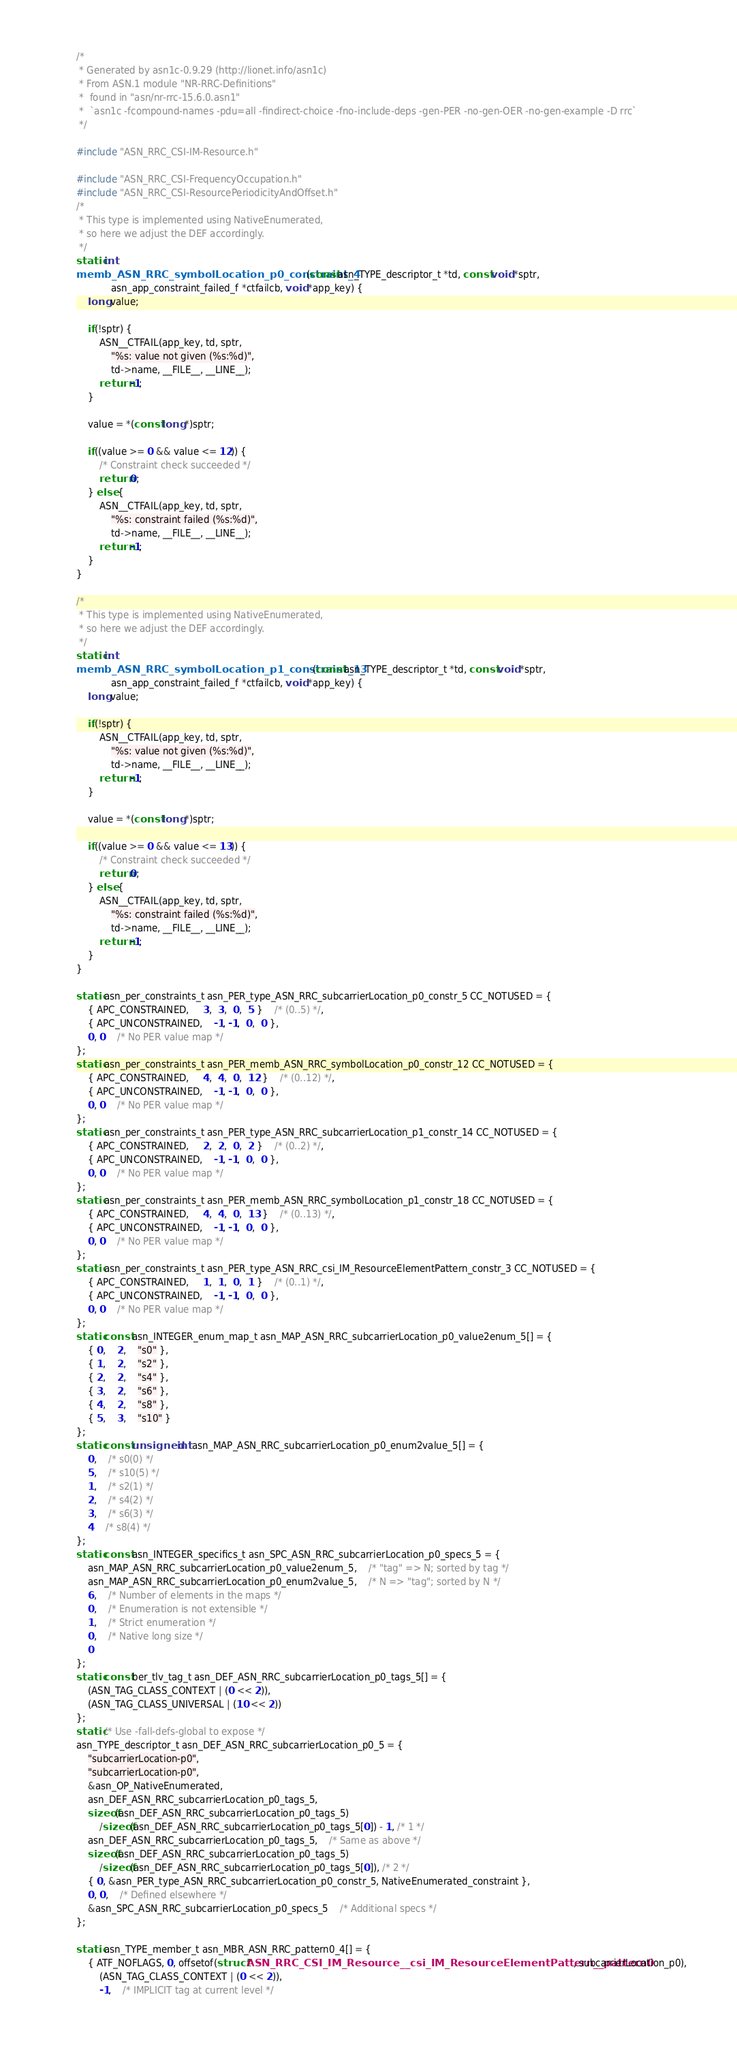<code> <loc_0><loc_0><loc_500><loc_500><_C_>/*
 * Generated by asn1c-0.9.29 (http://lionet.info/asn1c)
 * From ASN.1 module "NR-RRC-Definitions"
 * 	found in "asn/nr-rrc-15.6.0.asn1"
 * 	`asn1c -fcompound-names -pdu=all -findirect-choice -fno-include-deps -gen-PER -no-gen-OER -no-gen-example -D rrc`
 */

#include "ASN_RRC_CSI-IM-Resource.h"

#include "ASN_RRC_CSI-FrequencyOccupation.h"
#include "ASN_RRC_CSI-ResourcePeriodicityAndOffset.h"
/*
 * This type is implemented using NativeEnumerated,
 * so here we adjust the DEF accordingly.
 */
static int
memb_ASN_RRC_symbolLocation_p0_constraint_4(const asn_TYPE_descriptor_t *td, const void *sptr,
			asn_app_constraint_failed_f *ctfailcb, void *app_key) {
	long value;
	
	if(!sptr) {
		ASN__CTFAIL(app_key, td, sptr,
			"%s: value not given (%s:%d)",
			td->name, __FILE__, __LINE__);
		return -1;
	}
	
	value = *(const long *)sptr;
	
	if((value >= 0 && value <= 12)) {
		/* Constraint check succeeded */
		return 0;
	} else {
		ASN__CTFAIL(app_key, td, sptr,
			"%s: constraint failed (%s:%d)",
			td->name, __FILE__, __LINE__);
		return -1;
	}
}

/*
 * This type is implemented using NativeEnumerated,
 * so here we adjust the DEF accordingly.
 */
static int
memb_ASN_RRC_symbolLocation_p1_constraint_13(const asn_TYPE_descriptor_t *td, const void *sptr,
			asn_app_constraint_failed_f *ctfailcb, void *app_key) {
	long value;
	
	if(!sptr) {
		ASN__CTFAIL(app_key, td, sptr,
			"%s: value not given (%s:%d)",
			td->name, __FILE__, __LINE__);
		return -1;
	}
	
	value = *(const long *)sptr;
	
	if((value >= 0 && value <= 13)) {
		/* Constraint check succeeded */
		return 0;
	} else {
		ASN__CTFAIL(app_key, td, sptr,
			"%s: constraint failed (%s:%d)",
			td->name, __FILE__, __LINE__);
		return -1;
	}
}

static asn_per_constraints_t asn_PER_type_ASN_RRC_subcarrierLocation_p0_constr_5 CC_NOTUSED = {
	{ APC_CONSTRAINED,	 3,  3,  0,  5 }	/* (0..5) */,
	{ APC_UNCONSTRAINED,	-1, -1,  0,  0 },
	0, 0	/* No PER value map */
};
static asn_per_constraints_t asn_PER_memb_ASN_RRC_symbolLocation_p0_constr_12 CC_NOTUSED = {
	{ APC_CONSTRAINED,	 4,  4,  0,  12 }	/* (0..12) */,
	{ APC_UNCONSTRAINED,	-1, -1,  0,  0 },
	0, 0	/* No PER value map */
};
static asn_per_constraints_t asn_PER_type_ASN_RRC_subcarrierLocation_p1_constr_14 CC_NOTUSED = {
	{ APC_CONSTRAINED,	 2,  2,  0,  2 }	/* (0..2) */,
	{ APC_UNCONSTRAINED,	-1, -1,  0,  0 },
	0, 0	/* No PER value map */
};
static asn_per_constraints_t asn_PER_memb_ASN_RRC_symbolLocation_p1_constr_18 CC_NOTUSED = {
	{ APC_CONSTRAINED,	 4,  4,  0,  13 }	/* (0..13) */,
	{ APC_UNCONSTRAINED,	-1, -1,  0,  0 },
	0, 0	/* No PER value map */
};
static asn_per_constraints_t asn_PER_type_ASN_RRC_csi_IM_ResourceElementPattern_constr_3 CC_NOTUSED = {
	{ APC_CONSTRAINED,	 1,  1,  0,  1 }	/* (0..1) */,
	{ APC_UNCONSTRAINED,	-1, -1,  0,  0 },
	0, 0	/* No PER value map */
};
static const asn_INTEGER_enum_map_t asn_MAP_ASN_RRC_subcarrierLocation_p0_value2enum_5[] = {
	{ 0,	2,	"s0" },
	{ 1,	2,	"s2" },
	{ 2,	2,	"s4" },
	{ 3,	2,	"s6" },
	{ 4,	2,	"s8" },
	{ 5,	3,	"s10" }
};
static const unsigned int asn_MAP_ASN_RRC_subcarrierLocation_p0_enum2value_5[] = {
	0,	/* s0(0) */
	5,	/* s10(5) */
	1,	/* s2(1) */
	2,	/* s4(2) */
	3,	/* s6(3) */
	4	/* s8(4) */
};
static const asn_INTEGER_specifics_t asn_SPC_ASN_RRC_subcarrierLocation_p0_specs_5 = {
	asn_MAP_ASN_RRC_subcarrierLocation_p0_value2enum_5,	/* "tag" => N; sorted by tag */
	asn_MAP_ASN_RRC_subcarrierLocation_p0_enum2value_5,	/* N => "tag"; sorted by N */
	6,	/* Number of elements in the maps */
	0,	/* Enumeration is not extensible */
	1,	/* Strict enumeration */
	0,	/* Native long size */
	0
};
static const ber_tlv_tag_t asn_DEF_ASN_RRC_subcarrierLocation_p0_tags_5[] = {
	(ASN_TAG_CLASS_CONTEXT | (0 << 2)),
	(ASN_TAG_CLASS_UNIVERSAL | (10 << 2))
};
static /* Use -fall-defs-global to expose */
asn_TYPE_descriptor_t asn_DEF_ASN_RRC_subcarrierLocation_p0_5 = {
	"subcarrierLocation-p0",
	"subcarrierLocation-p0",
	&asn_OP_NativeEnumerated,
	asn_DEF_ASN_RRC_subcarrierLocation_p0_tags_5,
	sizeof(asn_DEF_ASN_RRC_subcarrierLocation_p0_tags_5)
		/sizeof(asn_DEF_ASN_RRC_subcarrierLocation_p0_tags_5[0]) - 1, /* 1 */
	asn_DEF_ASN_RRC_subcarrierLocation_p0_tags_5,	/* Same as above */
	sizeof(asn_DEF_ASN_RRC_subcarrierLocation_p0_tags_5)
		/sizeof(asn_DEF_ASN_RRC_subcarrierLocation_p0_tags_5[0]), /* 2 */
	{ 0, &asn_PER_type_ASN_RRC_subcarrierLocation_p0_constr_5, NativeEnumerated_constraint },
	0, 0,	/* Defined elsewhere */
	&asn_SPC_ASN_RRC_subcarrierLocation_p0_specs_5	/* Additional specs */
};

static asn_TYPE_member_t asn_MBR_ASN_RRC_pattern0_4[] = {
	{ ATF_NOFLAGS, 0, offsetof(struct ASN_RRC_CSI_IM_Resource__csi_IM_ResourceElementPattern__pattern0, subcarrierLocation_p0),
		(ASN_TAG_CLASS_CONTEXT | (0 << 2)),
		-1,	/* IMPLICIT tag at current level */</code> 